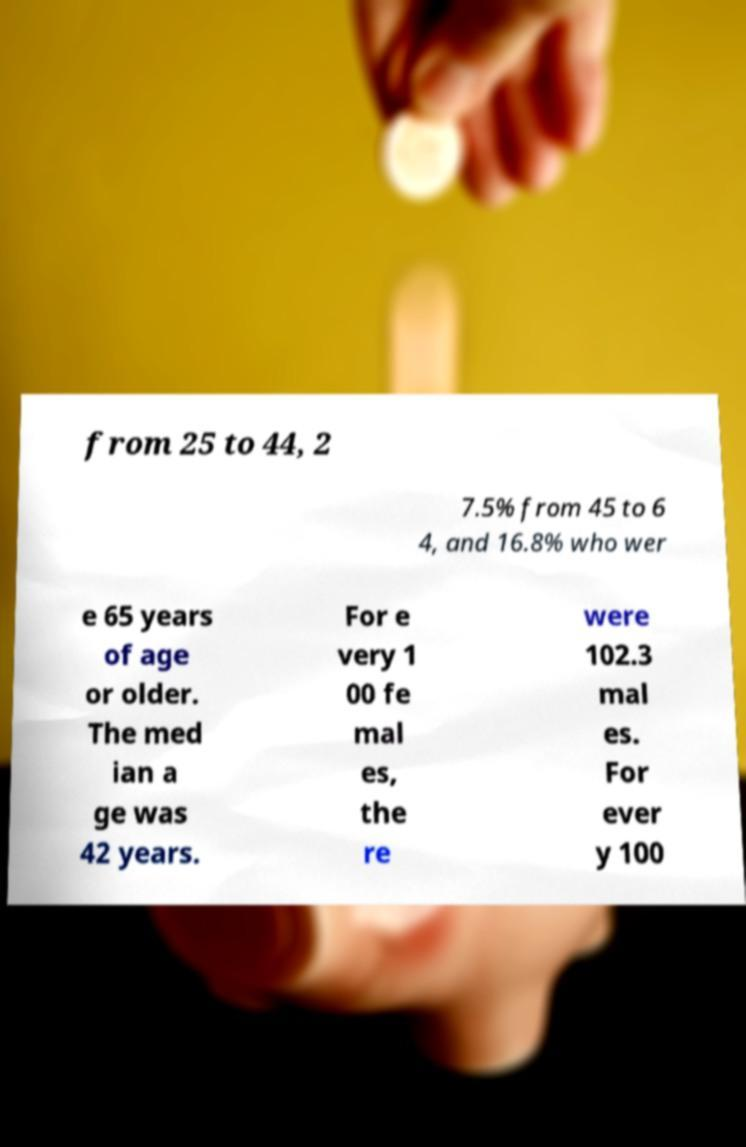Can you accurately transcribe the text from the provided image for me? from 25 to 44, 2 7.5% from 45 to 6 4, and 16.8% who wer e 65 years of age or older. The med ian a ge was 42 years. For e very 1 00 fe mal es, the re were 102.3 mal es. For ever y 100 